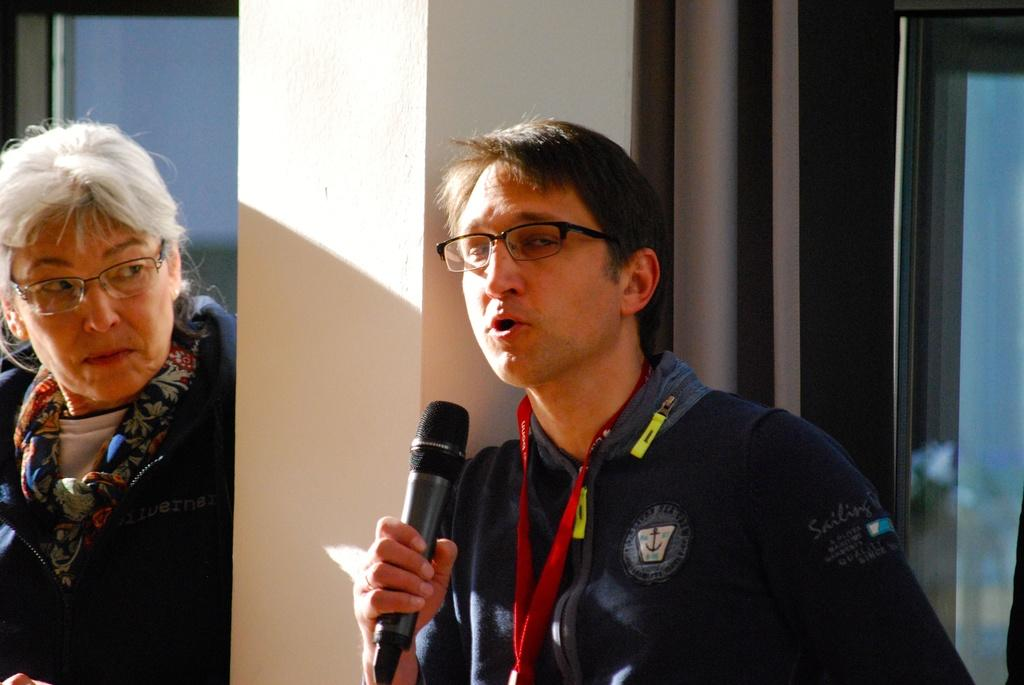Who is present in the image? There is a person in the image. What can be observed about the person's appearance? The person is wearing spectacles. Where is the person located in relation to the wall? The person is standing beside a wall. Are there any other individuals in the image? Yes, there is a lady in the image. What type of thumb is the person holding in the image? There is no thumb present in the image. What fact can be learned about the lady's profession from the image? The image does not provide any information about the lady's profession, so we cannot determine any facts about it. 